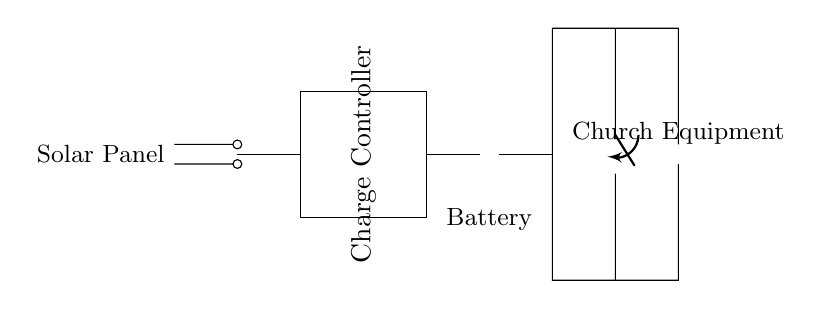What is the source of power in this circuit? The power source is the solar panel, which converts sunlight into electrical energy.
Answer: Solar panel What component regulates the charging process? The charge controller is responsible for managing the charging of the battery to prevent overcharging and ensure safe operation.
Answer: Charge controller What type of load is represented in this circuit? The load in the circuit is specified as church equipment, which likely refers to electrical devices used during outdoor events.
Answer: Church equipment What is the purpose of the switch in this circuit? The switch controls the flow of electricity to the load, allowing for the load to be turned on or off, thereby managing the operation of the connected devices.
Answer: To control load How do the solar panel and battery connect in the circuit? The solar panel connects directly to the charge controller, which then connects to the battery; this flow indicates that the solar panel charges the battery through the controller.
Answer: Directly to the charge controller What is the expected voltage at the battery? The voltage at the battery is specified as V_bat, which denotes the battery's voltage in the circuit, though the actual value is not provided in the diagram.
Answer: V_bat 